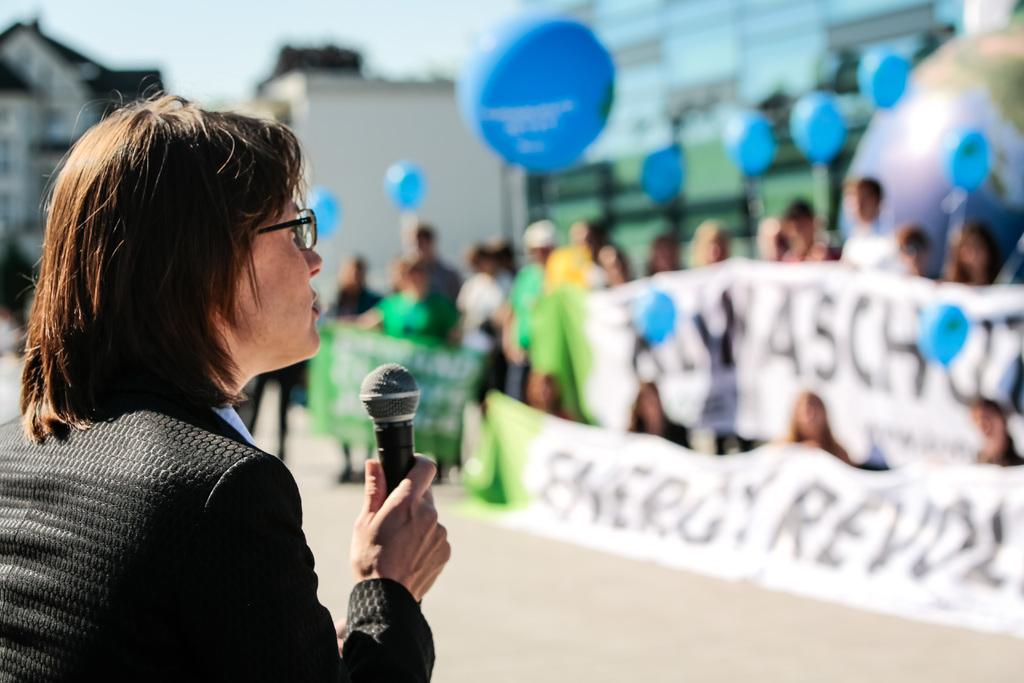Who is the main subject in the image? There is a woman in the image. What is the woman wearing? The woman is wearing a suit and spectacles. What is the woman holding in the image? The woman is holding a microphone. What can be seen in the background of the image? There are buildings visible in the background. What else is present in the image besides the woman and the buildings? There are people holding banners and balloons in the image. What rate of interest is the woman offering on the linen in the image? There is no mention of linen or interest rates in the image. The woman is holding a microphone and is likely speaking or performing, but there is no context to suggest she is offering any financial advice or products. 